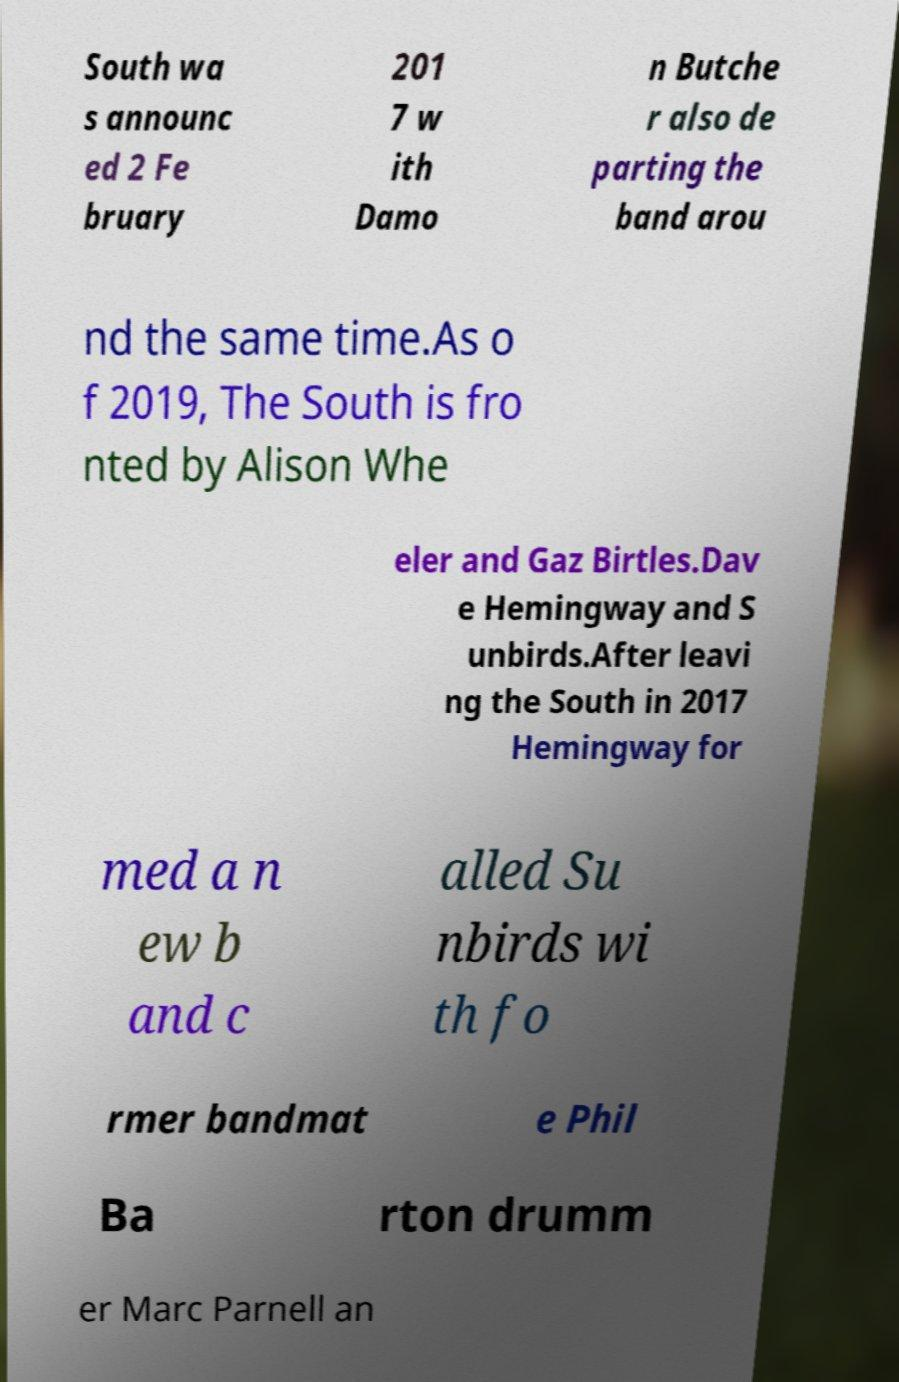What messages or text are displayed in this image? I need them in a readable, typed format. South wa s announc ed 2 Fe bruary 201 7 w ith Damo n Butche r also de parting the band arou nd the same time.As o f 2019, The South is fro nted by Alison Whe eler and Gaz Birtles.Dav e Hemingway and S unbirds.After leavi ng the South in 2017 Hemingway for med a n ew b and c alled Su nbirds wi th fo rmer bandmat e Phil Ba rton drumm er Marc Parnell an 